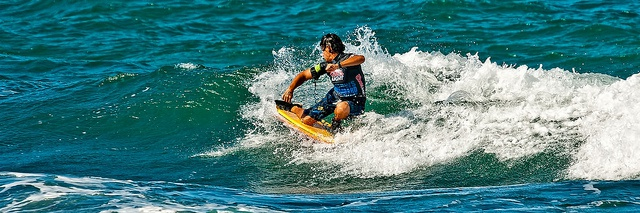Describe the objects in this image and their specific colors. I can see people in teal, black, darkgray, gray, and maroon tones and surfboard in teal, orange, tan, and khaki tones in this image. 